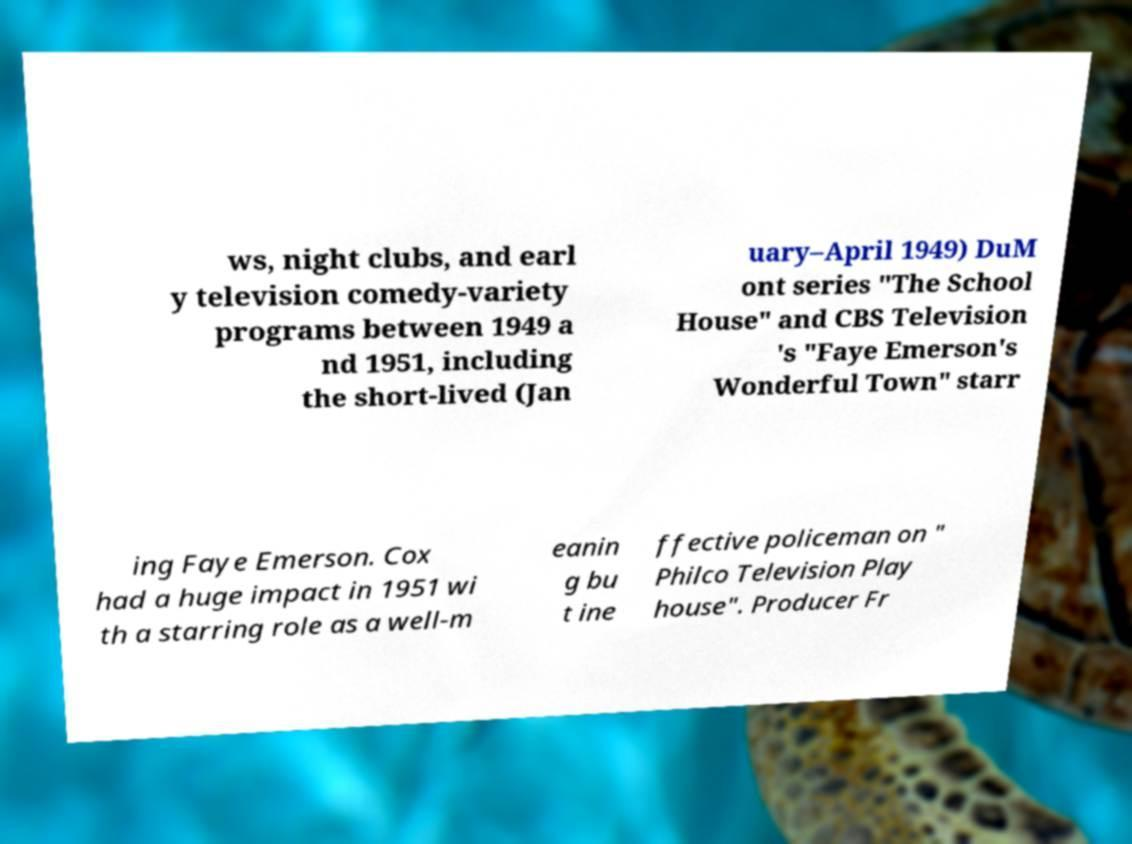Can you read and provide the text displayed in the image?This photo seems to have some interesting text. Can you extract and type it out for me? ws, night clubs, and earl y television comedy-variety programs between 1949 a nd 1951, including the short-lived (Jan uary–April 1949) DuM ont series "The School House" and CBS Television 's "Faye Emerson's Wonderful Town" starr ing Faye Emerson. Cox had a huge impact in 1951 wi th a starring role as a well-m eanin g bu t ine ffective policeman on " Philco Television Play house". Producer Fr 